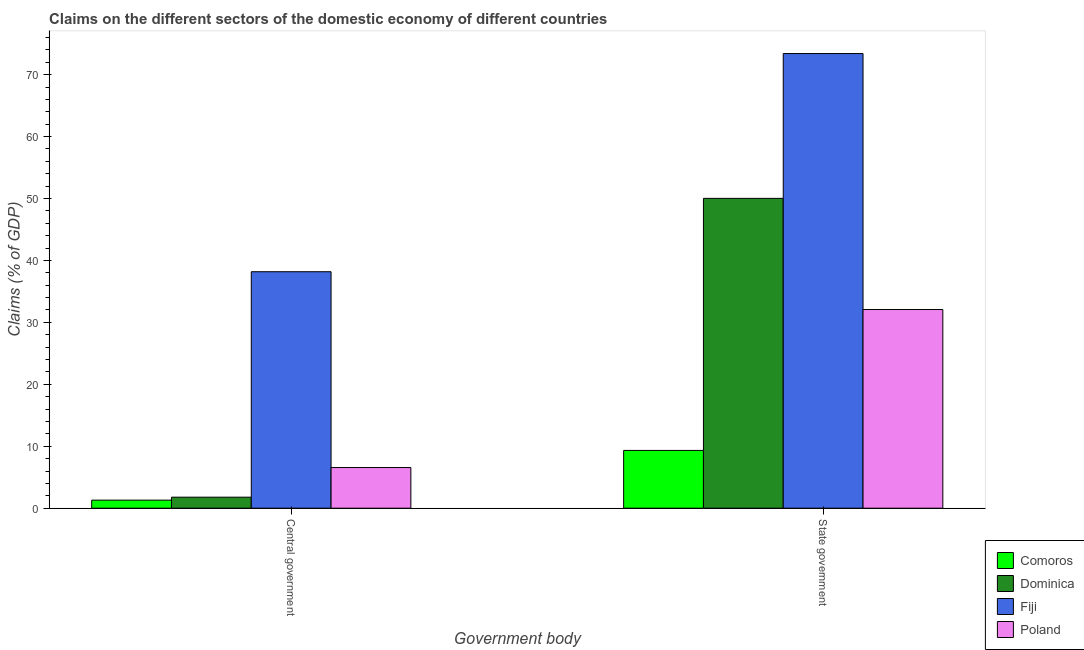Are the number of bars per tick equal to the number of legend labels?
Ensure brevity in your answer.  Yes. Are the number of bars on each tick of the X-axis equal?
Ensure brevity in your answer.  Yes. How many bars are there on the 1st tick from the left?
Make the answer very short. 4. What is the label of the 2nd group of bars from the left?
Make the answer very short. State government. What is the claims on central government in Poland?
Give a very brief answer. 6.56. Across all countries, what is the maximum claims on state government?
Keep it short and to the point. 73.4. Across all countries, what is the minimum claims on central government?
Provide a succinct answer. 1.3. In which country was the claims on central government maximum?
Give a very brief answer. Fiji. In which country was the claims on central government minimum?
Keep it short and to the point. Comoros. What is the total claims on central government in the graph?
Keep it short and to the point. 47.82. What is the difference between the claims on central government in Fiji and that in Poland?
Ensure brevity in your answer.  31.62. What is the difference between the claims on state government in Poland and the claims on central government in Fiji?
Make the answer very short. -6.1. What is the average claims on state government per country?
Offer a terse response. 41.21. What is the difference between the claims on state government and claims on central government in Poland?
Provide a succinct answer. 25.51. In how many countries, is the claims on central government greater than 14 %?
Your answer should be compact. 1. What is the ratio of the claims on central government in Dominica to that in Fiji?
Ensure brevity in your answer.  0.05. In how many countries, is the claims on state government greater than the average claims on state government taken over all countries?
Make the answer very short. 2. What does the 3rd bar from the right in State government represents?
Offer a very short reply. Dominica. Are all the bars in the graph horizontal?
Your answer should be compact. No. How many countries are there in the graph?
Ensure brevity in your answer.  4. Does the graph contain grids?
Offer a terse response. No. Where does the legend appear in the graph?
Make the answer very short. Bottom right. How many legend labels are there?
Provide a succinct answer. 4. How are the legend labels stacked?
Ensure brevity in your answer.  Vertical. What is the title of the graph?
Your response must be concise. Claims on the different sectors of the domestic economy of different countries. Does "Afghanistan" appear as one of the legend labels in the graph?
Your answer should be compact. No. What is the label or title of the X-axis?
Give a very brief answer. Government body. What is the label or title of the Y-axis?
Your response must be concise. Claims (% of GDP). What is the Claims (% of GDP) in Comoros in Central government?
Your response must be concise. 1.3. What is the Claims (% of GDP) in Dominica in Central government?
Offer a terse response. 1.78. What is the Claims (% of GDP) of Fiji in Central government?
Keep it short and to the point. 38.18. What is the Claims (% of GDP) in Poland in Central government?
Offer a very short reply. 6.56. What is the Claims (% of GDP) in Comoros in State government?
Provide a short and direct response. 9.33. What is the Claims (% of GDP) in Dominica in State government?
Your answer should be compact. 50.02. What is the Claims (% of GDP) of Fiji in State government?
Make the answer very short. 73.4. What is the Claims (% of GDP) in Poland in State government?
Offer a terse response. 32.08. Across all Government body, what is the maximum Claims (% of GDP) in Comoros?
Offer a terse response. 9.33. Across all Government body, what is the maximum Claims (% of GDP) in Dominica?
Keep it short and to the point. 50.02. Across all Government body, what is the maximum Claims (% of GDP) in Fiji?
Offer a very short reply. 73.4. Across all Government body, what is the maximum Claims (% of GDP) of Poland?
Your answer should be compact. 32.08. Across all Government body, what is the minimum Claims (% of GDP) in Comoros?
Offer a very short reply. 1.3. Across all Government body, what is the minimum Claims (% of GDP) of Dominica?
Give a very brief answer. 1.78. Across all Government body, what is the minimum Claims (% of GDP) of Fiji?
Keep it short and to the point. 38.18. Across all Government body, what is the minimum Claims (% of GDP) of Poland?
Your answer should be compact. 6.56. What is the total Claims (% of GDP) of Comoros in the graph?
Ensure brevity in your answer.  10.63. What is the total Claims (% of GDP) in Dominica in the graph?
Keep it short and to the point. 51.8. What is the total Claims (% of GDP) of Fiji in the graph?
Offer a terse response. 111.58. What is the total Claims (% of GDP) in Poland in the graph?
Offer a terse response. 38.64. What is the difference between the Claims (% of GDP) of Comoros in Central government and that in State government?
Your response must be concise. -8.03. What is the difference between the Claims (% of GDP) in Dominica in Central government and that in State government?
Your answer should be compact. -48.25. What is the difference between the Claims (% of GDP) of Fiji in Central government and that in State government?
Provide a short and direct response. -35.23. What is the difference between the Claims (% of GDP) of Poland in Central government and that in State government?
Your answer should be very brief. -25.51. What is the difference between the Claims (% of GDP) of Comoros in Central government and the Claims (% of GDP) of Dominica in State government?
Your answer should be compact. -48.72. What is the difference between the Claims (% of GDP) in Comoros in Central government and the Claims (% of GDP) in Fiji in State government?
Provide a succinct answer. -72.1. What is the difference between the Claims (% of GDP) in Comoros in Central government and the Claims (% of GDP) in Poland in State government?
Your response must be concise. -30.77. What is the difference between the Claims (% of GDP) of Dominica in Central government and the Claims (% of GDP) of Fiji in State government?
Make the answer very short. -71.63. What is the difference between the Claims (% of GDP) in Dominica in Central government and the Claims (% of GDP) in Poland in State government?
Provide a short and direct response. -30.3. What is the difference between the Claims (% of GDP) of Fiji in Central government and the Claims (% of GDP) of Poland in State government?
Offer a terse response. 6.1. What is the average Claims (% of GDP) of Comoros per Government body?
Offer a very short reply. 5.32. What is the average Claims (% of GDP) in Dominica per Government body?
Offer a terse response. 25.9. What is the average Claims (% of GDP) in Fiji per Government body?
Provide a succinct answer. 55.79. What is the average Claims (% of GDP) in Poland per Government body?
Your answer should be compact. 19.32. What is the difference between the Claims (% of GDP) in Comoros and Claims (% of GDP) in Dominica in Central government?
Offer a terse response. -0.48. What is the difference between the Claims (% of GDP) of Comoros and Claims (% of GDP) of Fiji in Central government?
Offer a very short reply. -36.88. What is the difference between the Claims (% of GDP) of Comoros and Claims (% of GDP) of Poland in Central government?
Offer a very short reply. -5.26. What is the difference between the Claims (% of GDP) in Dominica and Claims (% of GDP) in Fiji in Central government?
Keep it short and to the point. -36.4. What is the difference between the Claims (% of GDP) of Dominica and Claims (% of GDP) of Poland in Central government?
Offer a very short reply. -4.79. What is the difference between the Claims (% of GDP) of Fiji and Claims (% of GDP) of Poland in Central government?
Ensure brevity in your answer.  31.62. What is the difference between the Claims (% of GDP) in Comoros and Claims (% of GDP) in Dominica in State government?
Give a very brief answer. -40.7. What is the difference between the Claims (% of GDP) of Comoros and Claims (% of GDP) of Fiji in State government?
Make the answer very short. -64.08. What is the difference between the Claims (% of GDP) in Comoros and Claims (% of GDP) in Poland in State government?
Your answer should be compact. -22.75. What is the difference between the Claims (% of GDP) in Dominica and Claims (% of GDP) in Fiji in State government?
Keep it short and to the point. -23.38. What is the difference between the Claims (% of GDP) of Dominica and Claims (% of GDP) of Poland in State government?
Offer a terse response. 17.95. What is the difference between the Claims (% of GDP) in Fiji and Claims (% of GDP) in Poland in State government?
Give a very brief answer. 41.33. What is the ratio of the Claims (% of GDP) in Comoros in Central government to that in State government?
Give a very brief answer. 0.14. What is the ratio of the Claims (% of GDP) of Dominica in Central government to that in State government?
Give a very brief answer. 0.04. What is the ratio of the Claims (% of GDP) in Fiji in Central government to that in State government?
Make the answer very short. 0.52. What is the ratio of the Claims (% of GDP) of Poland in Central government to that in State government?
Your response must be concise. 0.2. What is the difference between the highest and the second highest Claims (% of GDP) in Comoros?
Provide a succinct answer. 8.03. What is the difference between the highest and the second highest Claims (% of GDP) of Dominica?
Keep it short and to the point. 48.25. What is the difference between the highest and the second highest Claims (% of GDP) in Fiji?
Your response must be concise. 35.23. What is the difference between the highest and the second highest Claims (% of GDP) in Poland?
Ensure brevity in your answer.  25.51. What is the difference between the highest and the lowest Claims (% of GDP) of Comoros?
Provide a succinct answer. 8.03. What is the difference between the highest and the lowest Claims (% of GDP) in Dominica?
Your answer should be very brief. 48.25. What is the difference between the highest and the lowest Claims (% of GDP) of Fiji?
Offer a very short reply. 35.23. What is the difference between the highest and the lowest Claims (% of GDP) of Poland?
Offer a terse response. 25.51. 